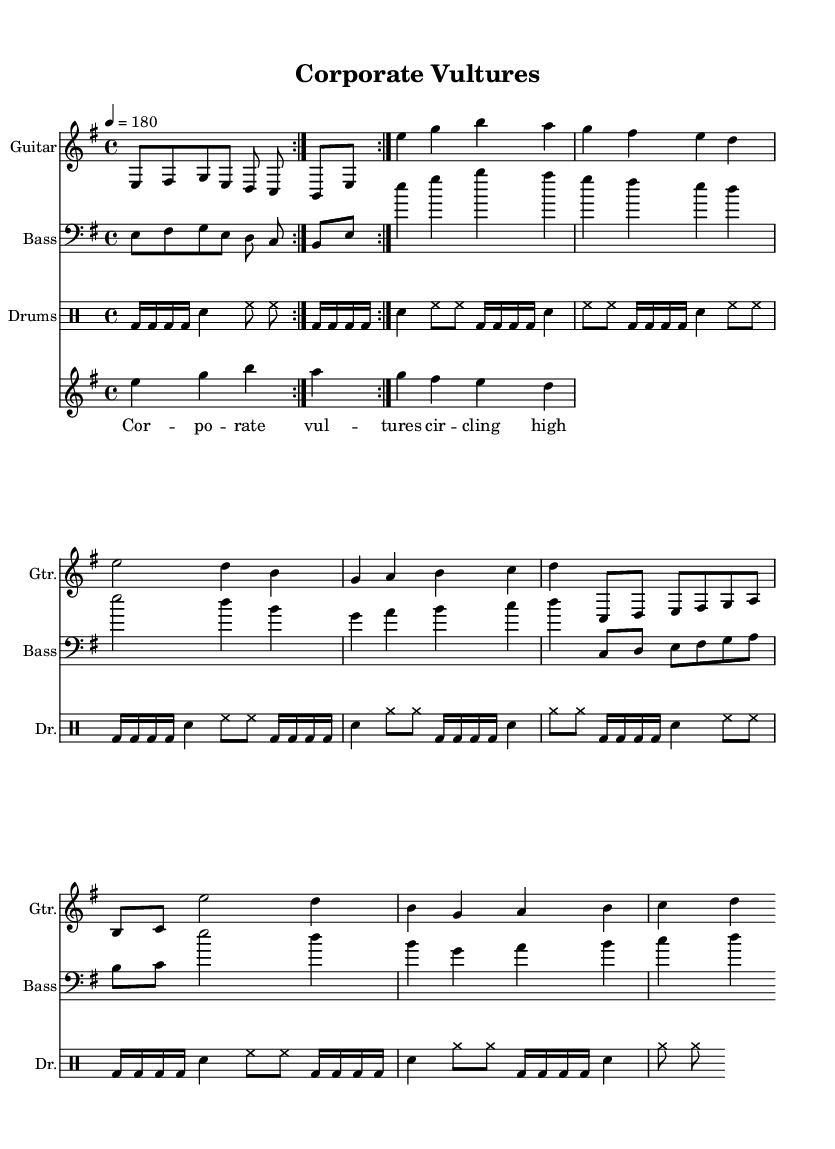What is the key signature of this music? The key signature is E minor, which typically has one sharp (F#). This can be deduced from the beginning of the score, where the one sharp is indicated.
Answer: E minor What is the time signature of this piece? The time signature is 4/4, as shown at the beginning of the score. This means there are four beats in each measure, and the quarter note receives one beat.
Answer: 4/4 What is the tempo marking for this music? The tempo is marked as 180 beats per minute. This is indicated in the tempo section of the score, showing that the music should be played at a fast and aggressive pace typical for thrash metal.
Answer: 180 How many times is the main riff repeated? The main riff is repeated twice, as indicated by the "repeat volta 2" instruction before the main riff notation. This signifies that the musician should play that section two times before moving on.
Answer: 2 What instrument plays the vocals? The vocals part is sung, and there are lyrics provided specifically for this part of the score. The lyrics are positioned under the main melody line, explicitly showing that this part is intended for the vocalist.
Answer: Vocals What kind of guitar is this piece for? The guitar part is for electric guitar, which is common in metal music to achieve the aggressive sound characteristic of the genre. The notation shows standard guitar notation which is typical for electric guitar performances.
Answer: Electric guitar Which musical section follows the verse? The chorus follows the verse, as indicated by the layout and structure of the score. After completing the verse line, the score references moving directly into the chorus section.
Answer: Chorus 